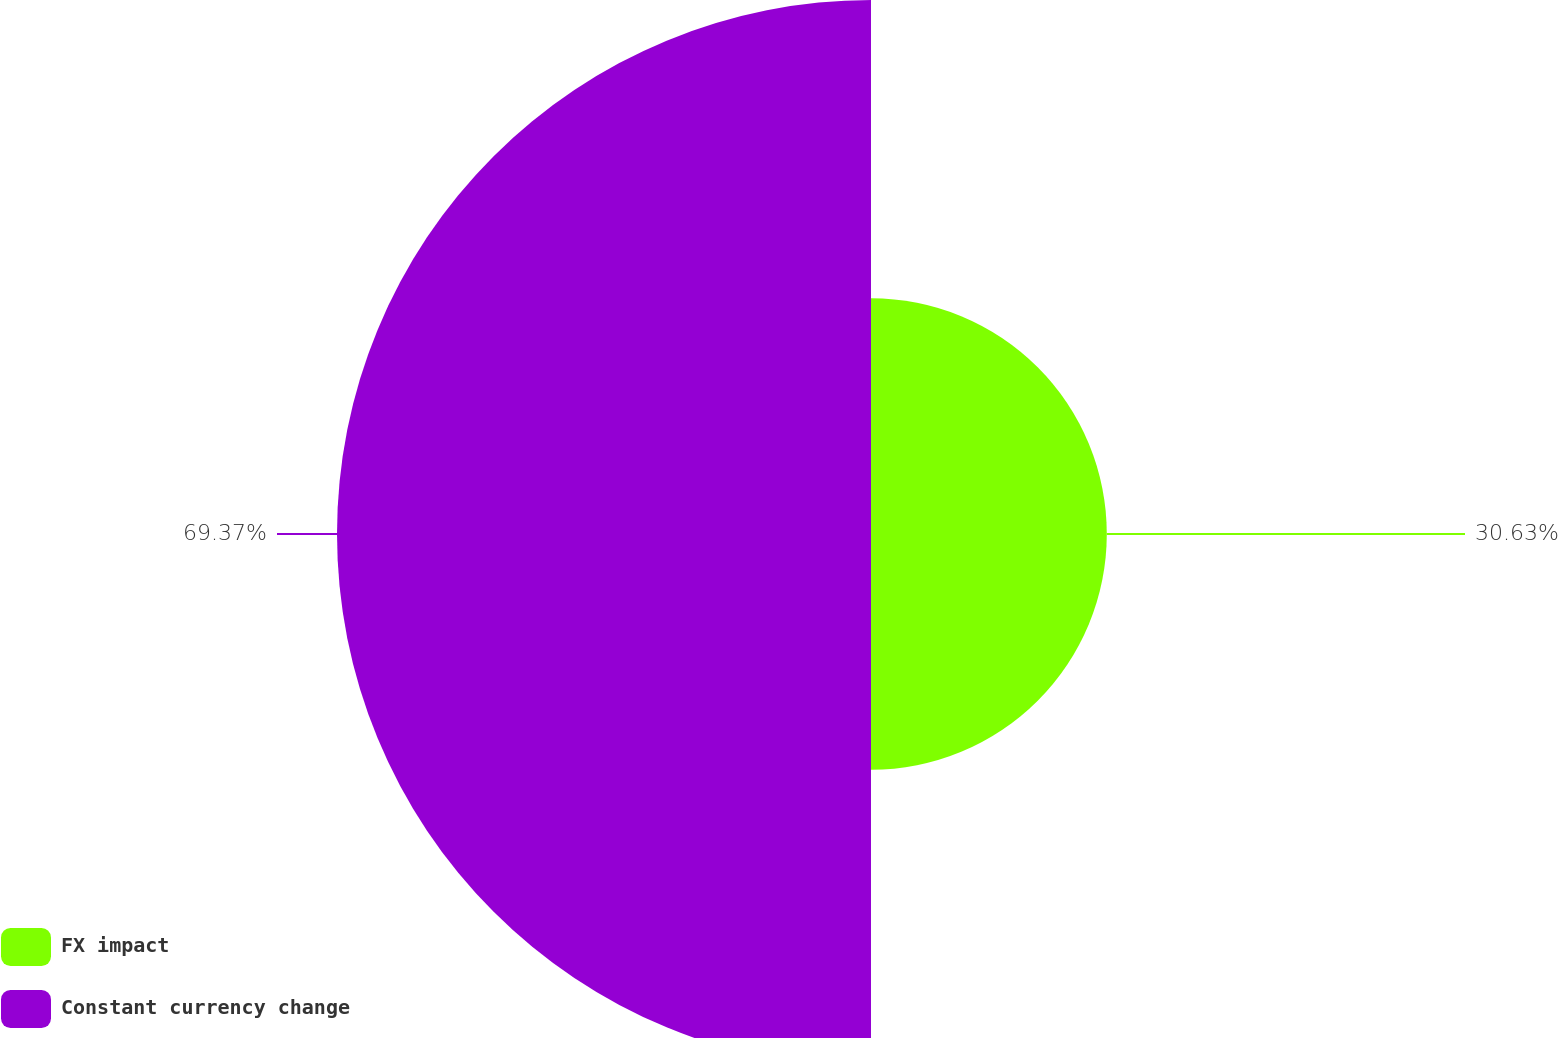Convert chart. <chart><loc_0><loc_0><loc_500><loc_500><pie_chart><fcel>FX impact<fcel>Constant currency change<nl><fcel>30.63%<fcel>69.37%<nl></chart> 